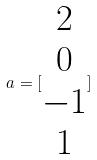<formula> <loc_0><loc_0><loc_500><loc_500>a = [ \begin{matrix} 2 \\ 0 \\ - 1 \\ 1 \end{matrix} ]</formula> 